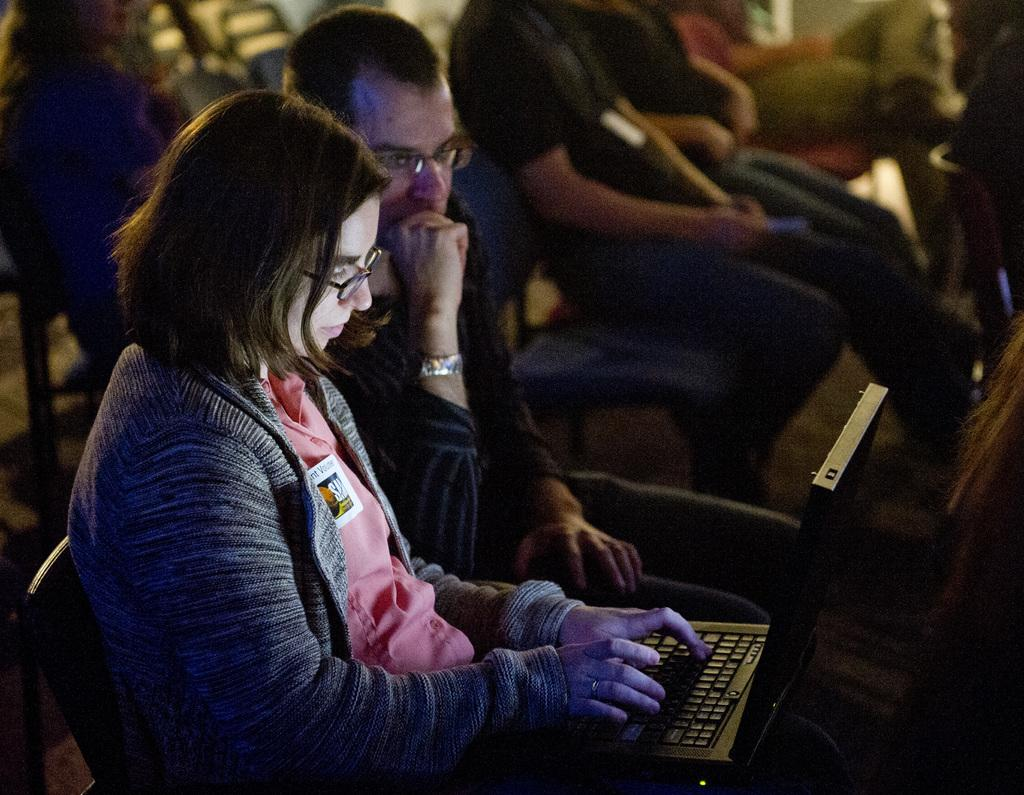What are the people in the image doing? The people in the image are sitting on chairs. Can you describe the activity of the lady in the foreground? The lady in the foreground is using a laptop. What can be seen in the background of the image? There are chairs and a person in the background of the image. What type of arithmetic problem is the scarecrow solving in the image? There is no scarecrow present in the image, so it cannot be determined if any arithmetic problem is being solved. 